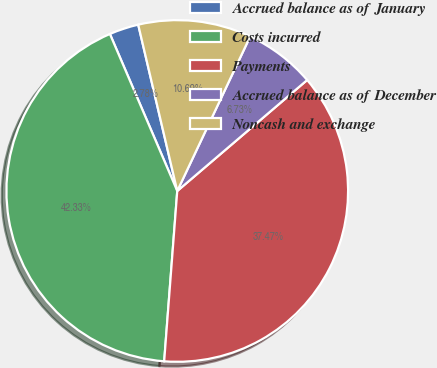Convert chart. <chart><loc_0><loc_0><loc_500><loc_500><pie_chart><fcel>Accrued balance as of January<fcel>Costs incurred<fcel>Payments<fcel>Accrued balance as of December<fcel>Noncash and exchange<nl><fcel>2.78%<fcel>42.33%<fcel>37.47%<fcel>6.73%<fcel>10.69%<nl></chart> 